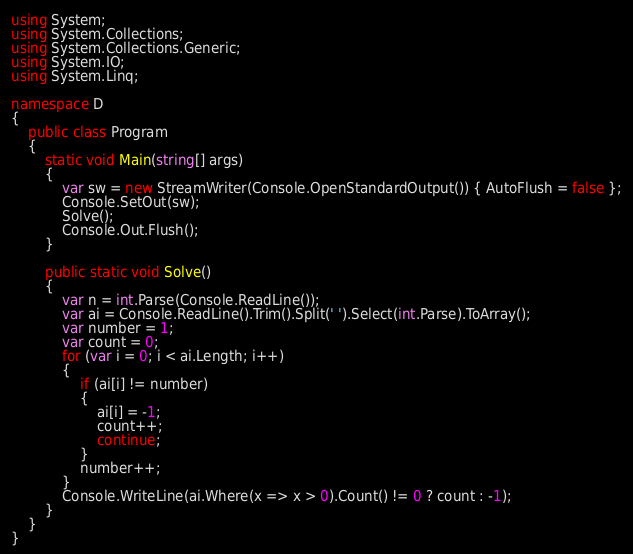<code> <loc_0><loc_0><loc_500><loc_500><_C#_>using System;
using System.Collections;
using System.Collections.Generic;
using System.IO;
using System.Linq;

namespace D
{
    public class Program
    {
        static void Main(string[] args)
        {
            var sw = new StreamWriter(Console.OpenStandardOutput()) { AutoFlush = false };
            Console.SetOut(sw);
            Solve();
            Console.Out.Flush();
        }

        public static void Solve()
        {
            var n = int.Parse(Console.ReadLine());
            var ai = Console.ReadLine().Trim().Split(' ').Select(int.Parse).ToArray();
            var number = 1;
            var count = 0;
            for (var i = 0; i < ai.Length; i++)
            {
                if (ai[i] != number)
                {
                    ai[i] = -1;
                    count++;
                    continue;
                }
                number++;
            }
            Console.WriteLine(ai.Where(x => x > 0).Count() != 0 ? count : -1);
        }
    }
}
</code> 